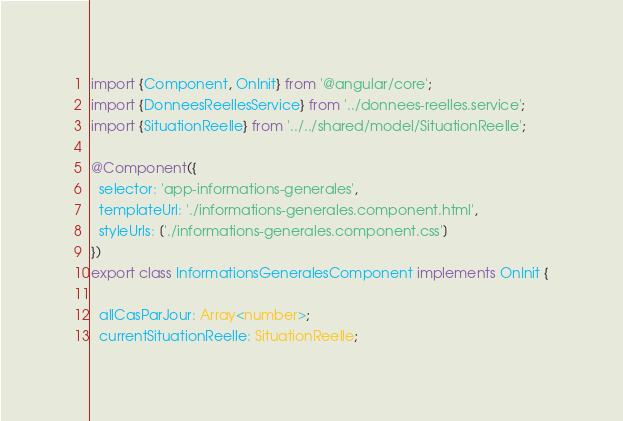Convert code to text. <code><loc_0><loc_0><loc_500><loc_500><_TypeScript_>import {Component, OnInit} from '@angular/core';
import {DonneesReellesService} from '../donnees-reelles.service';
import {SituationReelle} from '../../shared/model/SituationReelle';

@Component({
  selector: 'app-informations-generales',
  templateUrl: './informations-generales.component.html',
  styleUrls: ['./informations-generales.component.css']
})
export class InformationsGeneralesComponent implements OnInit {

  allCasParJour: Array<number>;
  currentSituationReelle: SituationReelle;
</code> 